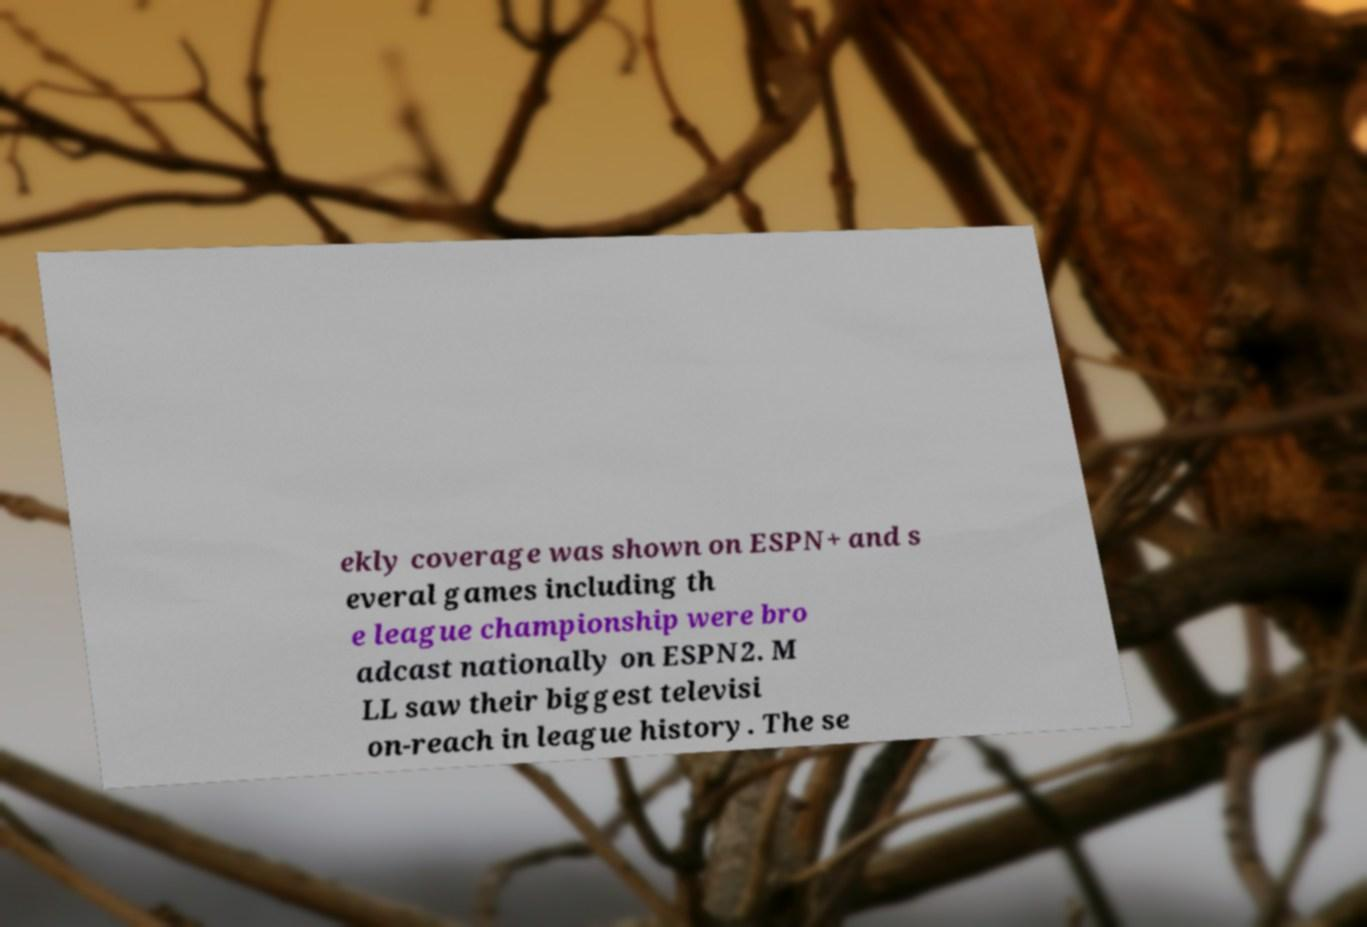What messages or text are displayed in this image? I need them in a readable, typed format. ekly coverage was shown on ESPN+ and s everal games including th e league championship were bro adcast nationally on ESPN2. M LL saw their biggest televisi on-reach in league history. The se 